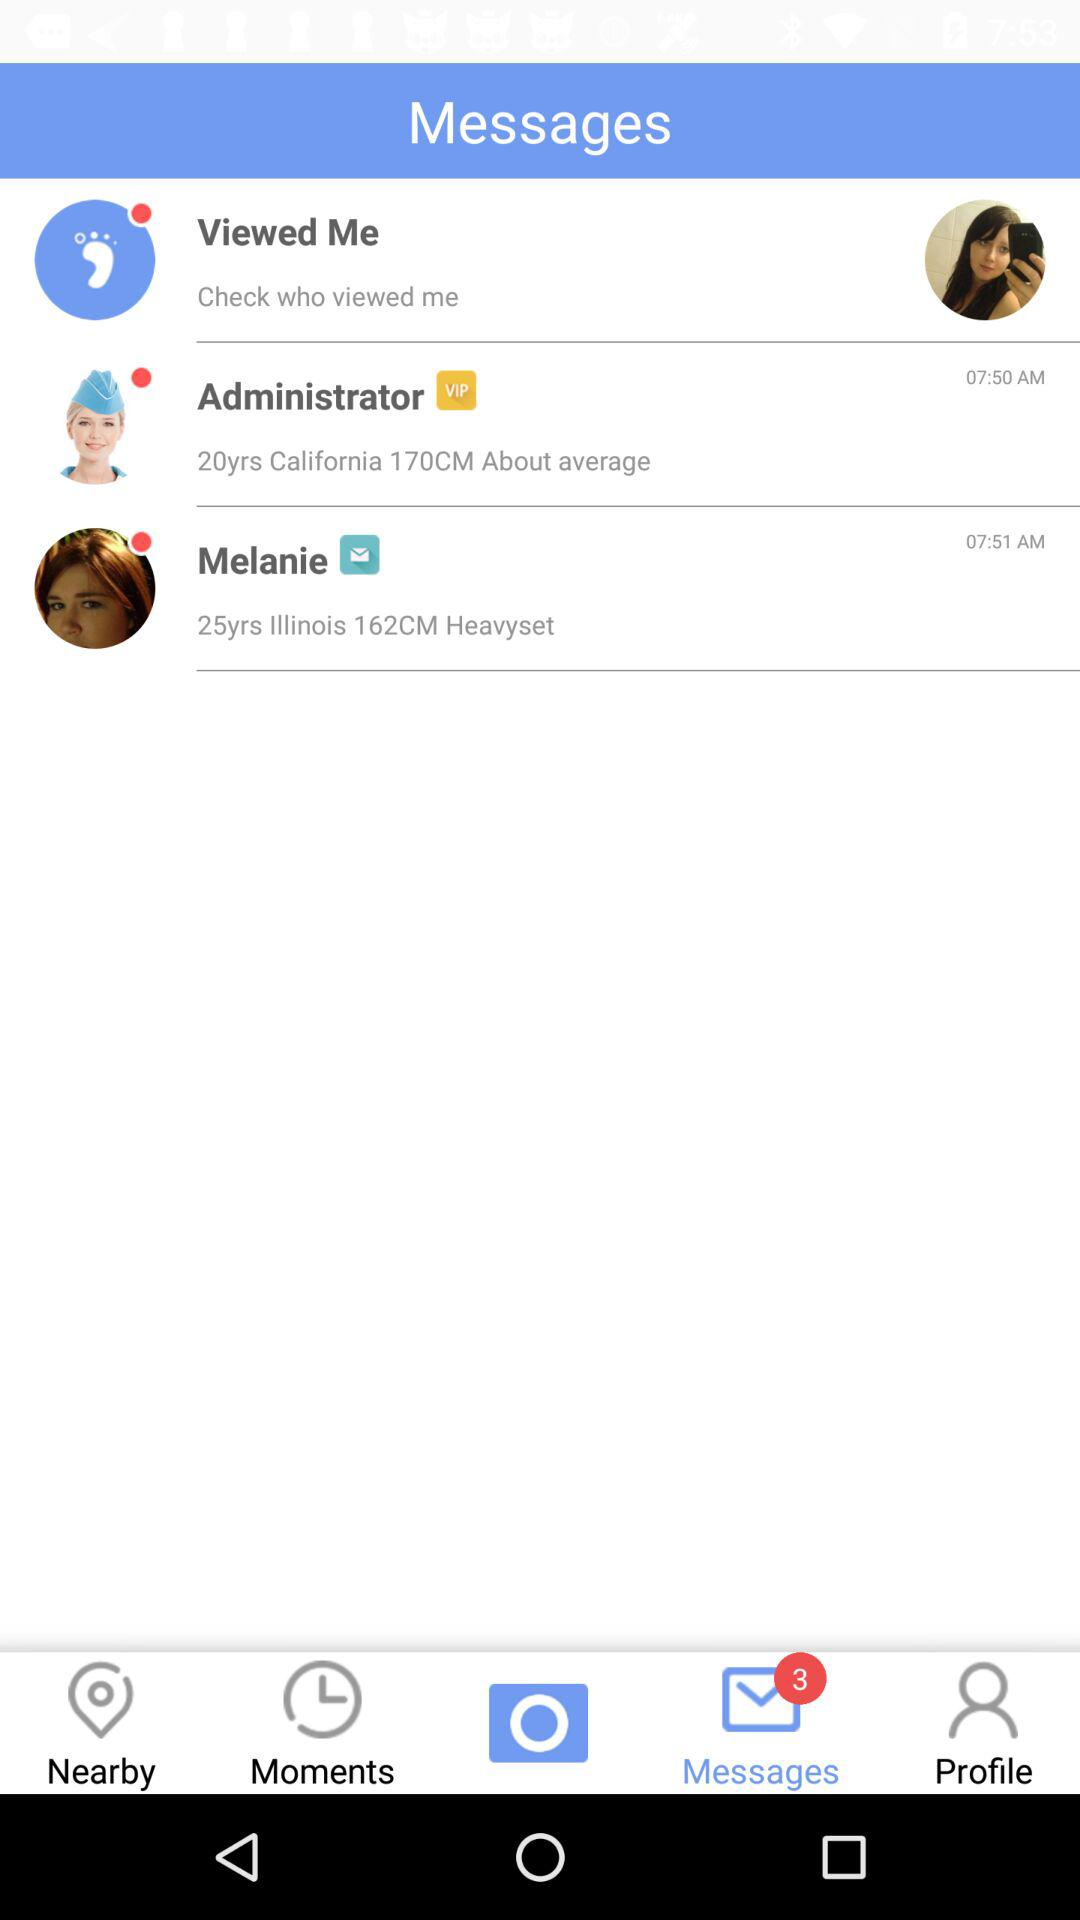What is the age of Melanie? Melanie's age is 25 years old. 